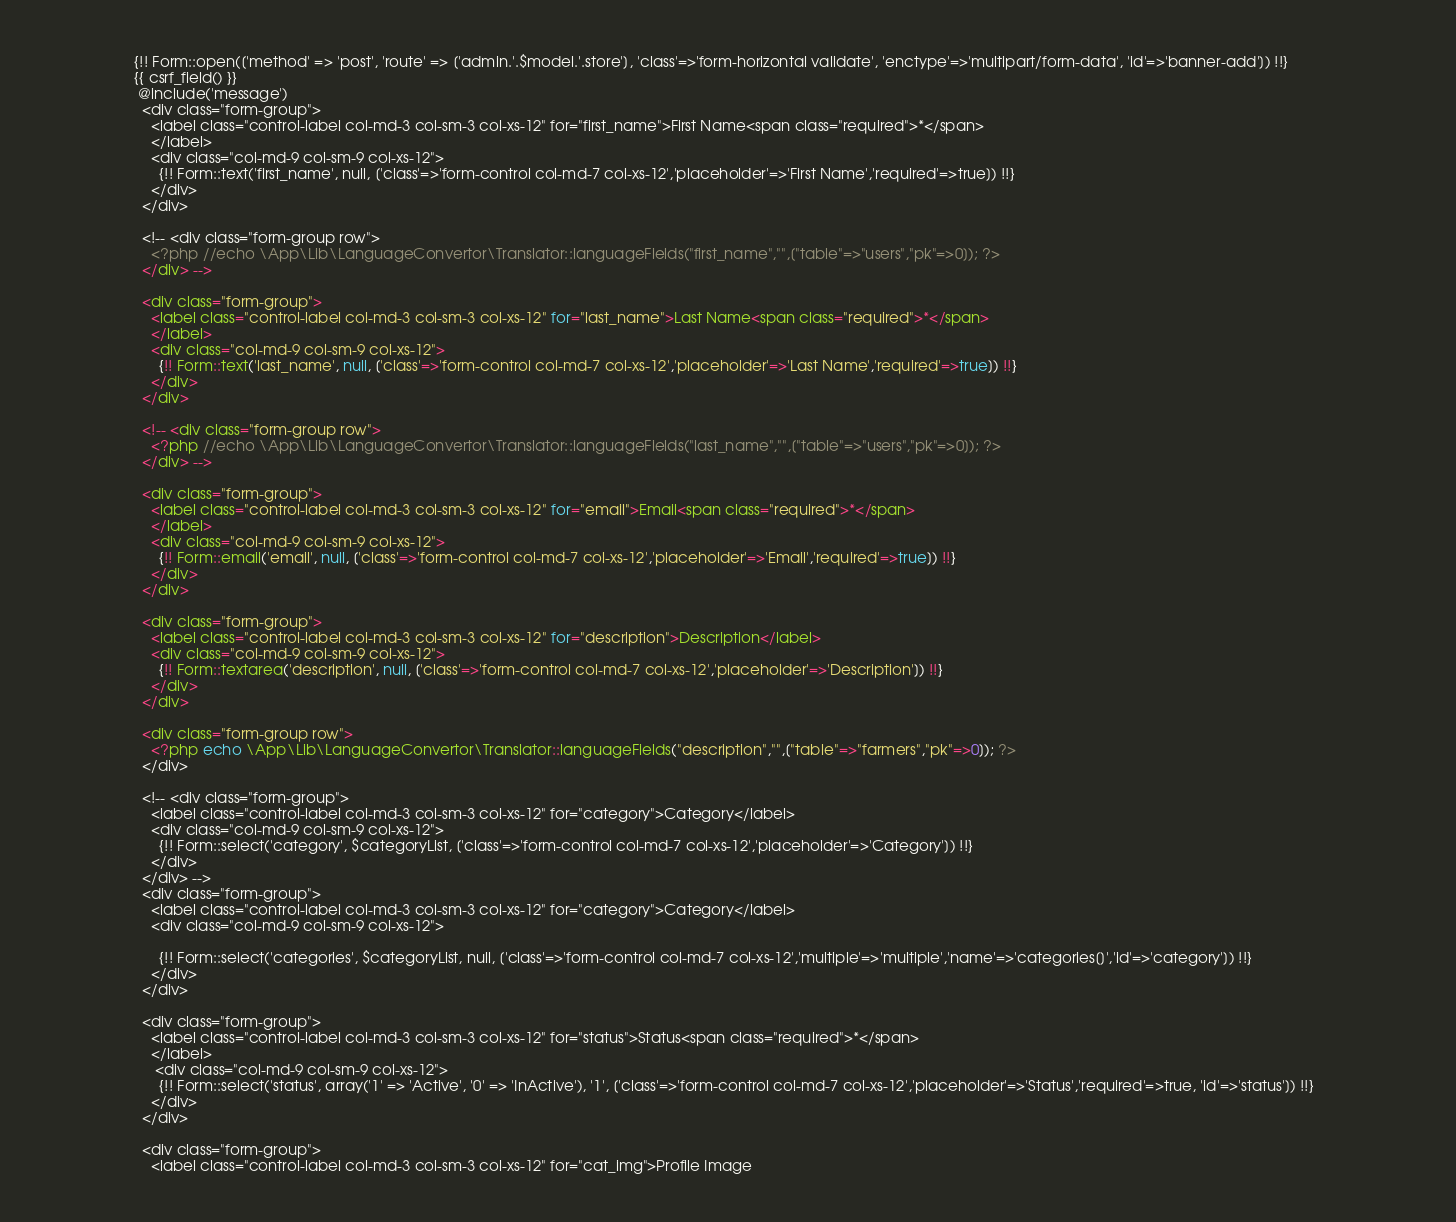Convert code to text. <code><loc_0><loc_0><loc_500><loc_500><_PHP_>                    {!! Form::open(['method' => 'post', 'route' => ['admin.'.$model.'.store'], 'class'=>'form-horizontal validate', 'enctype'=>'multipart/form-data', 'id'=>'banner-add']) !!}
                    {{ csrf_field() }}
                     @include('message')
                      <div class="form-group">
                        <label class="control-label col-md-3 col-sm-3 col-xs-12" for="first_name">First Name<span class="required">*</span>
                        </label>
                        <div class="col-md-9 col-sm-9 col-xs-12">
                          {!! Form::text('first_name', null, ['class'=>'form-control col-md-7 col-xs-12','placeholder'=>'First Name','required'=>true]) !!}
                        </div>
                      </div>

                      <!-- <div class="form-group row">
                        <?php //echo \App\Lib\LanguageConvertor\Translator::languageFields("first_name","",["table"=>"users","pk"=>0]); ?>
                      </div> -->

                      <div class="form-group">
                        <label class="control-label col-md-3 col-sm-3 col-xs-12" for="last_name">Last Name<span class="required">*</span>
                        </label>
                        <div class="col-md-9 col-sm-9 col-xs-12">
                          {!! Form::text('last_name', null, ['class'=>'form-control col-md-7 col-xs-12','placeholder'=>'Last Name','required'=>true]) !!}                      
                        </div>
                      </div>

                      <!-- <div class="form-group row">
                        <?php //echo \App\Lib\LanguageConvertor\Translator::languageFields("last_name","",["table"=>"users","pk"=>0]); ?>
                      </div> -->

                      <div class="form-group">
                        <label class="control-label col-md-3 col-sm-3 col-xs-12" for="email">Email<span class="required">*</span>
                        </label>
                        <div class="col-md-9 col-sm-9 col-xs-12">
                          {!! Form::email('email', null, ['class'=>'form-control col-md-7 col-xs-12','placeholder'=>'Email','required'=>true]) !!}
                        </div>
                      </div>

                      <div class="form-group">
                        <label class="control-label col-md-3 col-sm-3 col-xs-12" for="description">Description</label>
                        <div class="col-md-9 col-sm-9 col-xs-12">
                          {!! Form::textarea('description', null, ['class'=>'form-control col-md-7 col-xs-12','placeholder'=>'Description']) !!}                      
                        </div>
                      </div>
                      
                      <div class="form-group row">
                        <?php echo \App\Lib\LanguageConvertor\Translator::languageFields("description","",["table"=>"farmers","pk"=>0]); ?>
                      </div>

                      <!-- <div class="form-group">
                        <label class="control-label col-md-3 col-sm-3 col-xs-12" for="category">Category</label>
                        <div class="col-md-9 col-sm-9 col-xs-12">
                          {!! Form::select('category', $categoryList, ['class'=>'form-control col-md-7 col-xs-12','placeholder'=>'Category']) !!}                      
                        </div>
                      </div> -->
                      <div class="form-group">
                        <label class="control-label col-md-3 col-sm-3 col-xs-12" for="category">Category</label>
                        <div class="col-md-9 col-sm-9 col-xs-12">
                          
                          {!! Form::select('categories', $categoryList, null, ['class'=>'form-control col-md-7 col-xs-12','multiple'=>'multiple','name'=>'categories[]','id'=>'category']) !!}
                        </div>
                      </div>

                      <div class="form-group">
                        <label class="control-label col-md-3 col-sm-3 col-xs-12" for="status">Status<span class="required">*</span>
                        </label>
                         <div class="col-md-9 col-sm-9 col-xs-12">
                          {!! Form::select('status', array('1' => 'Active', '0' => 'InActive'), '1', ['class'=>'form-control col-md-7 col-xs-12','placeholder'=>'Status','required'=>true, 'id'=>'status']) !!}                      
                        </div>
                      </div>

                      <div class="form-group">
                        <label class="control-label col-md-3 col-sm-3 col-xs-12" for="cat_img">Profile Image</code> 